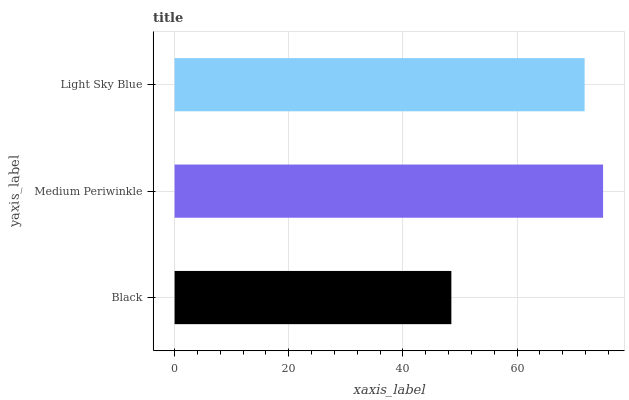Is Black the minimum?
Answer yes or no. Yes. Is Medium Periwinkle the maximum?
Answer yes or no. Yes. Is Light Sky Blue the minimum?
Answer yes or no. No. Is Light Sky Blue the maximum?
Answer yes or no. No. Is Medium Periwinkle greater than Light Sky Blue?
Answer yes or no. Yes. Is Light Sky Blue less than Medium Periwinkle?
Answer yes or no. Yes. Is Light Sky Blue greater than Medium Periwinkle?
Answer yes or no. No. Is Medium Periwinkle less than Light Sky Blue?
Answer yes or no. No. Is Light Sky Blue the high median?
Answer yes or no. Yes. Is Light Sky Blue the low median?
Answer yes or no. Yes. Is Medium Periwinkle the high median?
Answer yes or no. No. Is Black the low median?
Answer yes or no. No. 